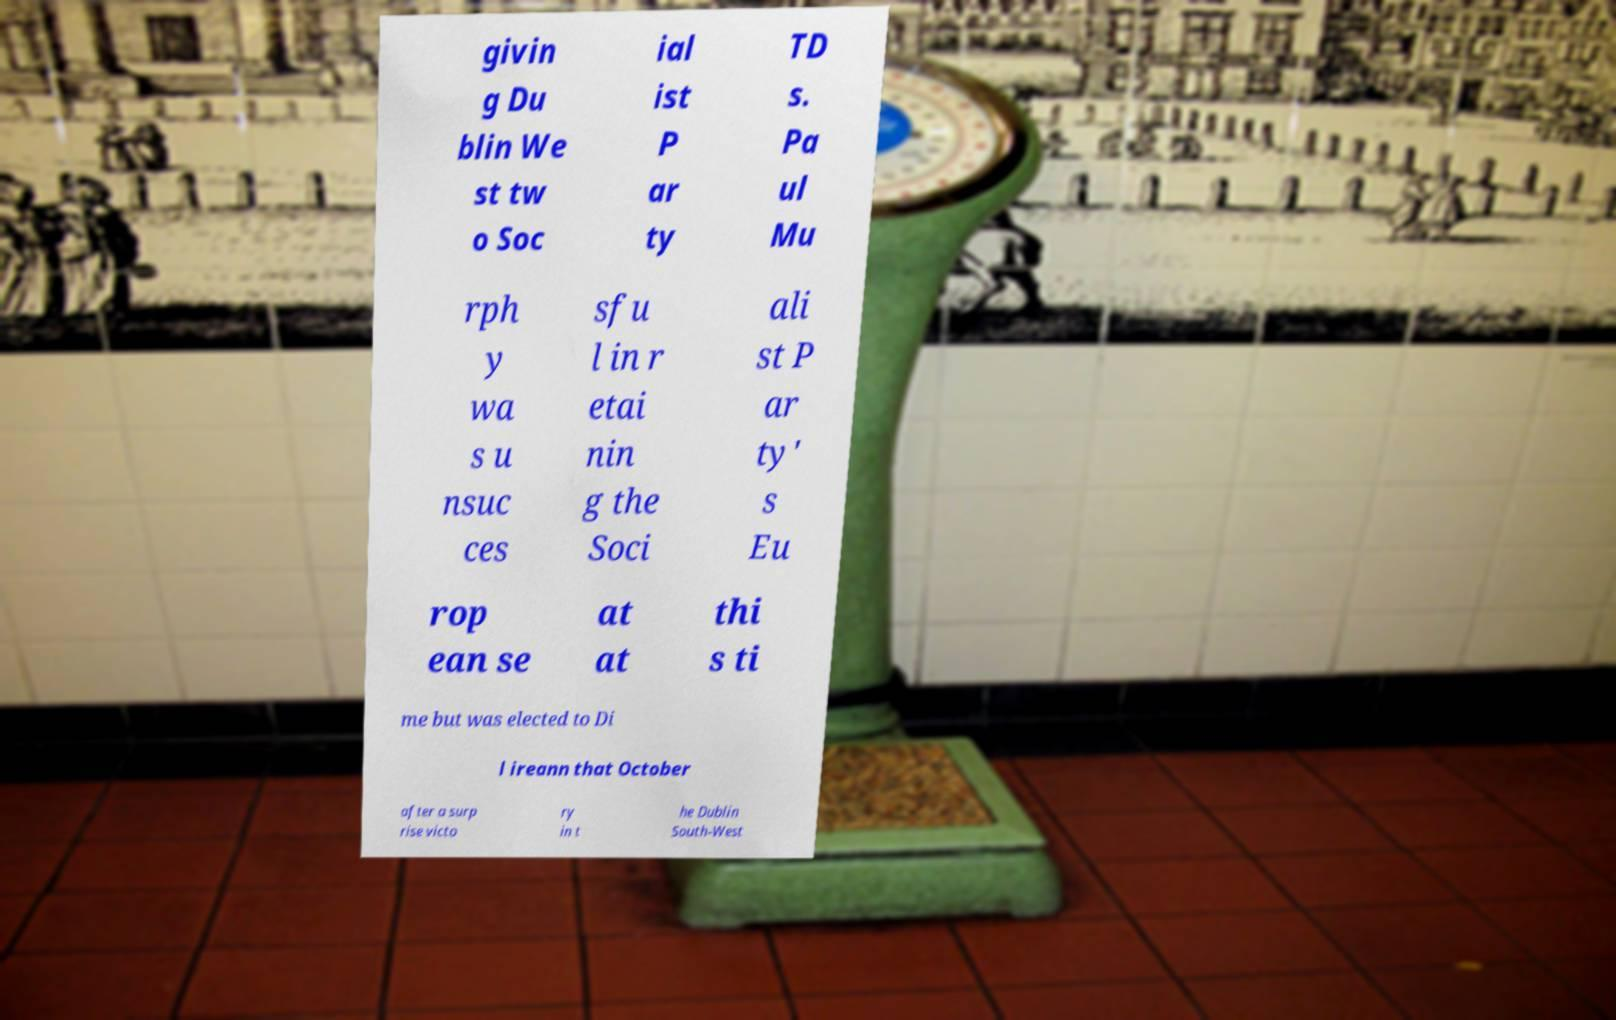I need the written content from this picture converted into text. Can you do that? givin g Du blin We st tw o Soc ial ist P ar ty TD s. Pa ul Mu rph y wa s u nsuc ces sfu l in r etai nin g the Soci ali st P ar ty' s Eu rop ean se at at thi s ti me but was elected to Di l ireann that October after a surp rise victo ry in t he Dublin South-West 